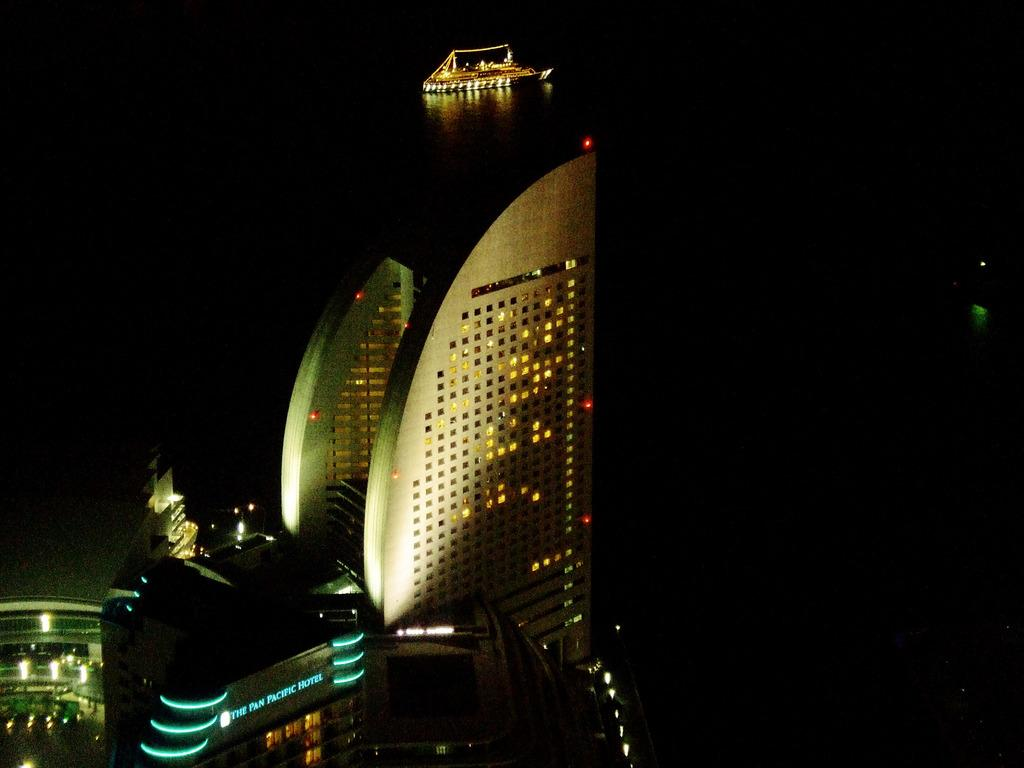<image>
Summarize the visual content of the image. the outside of the pan pacific hotel with lights on 